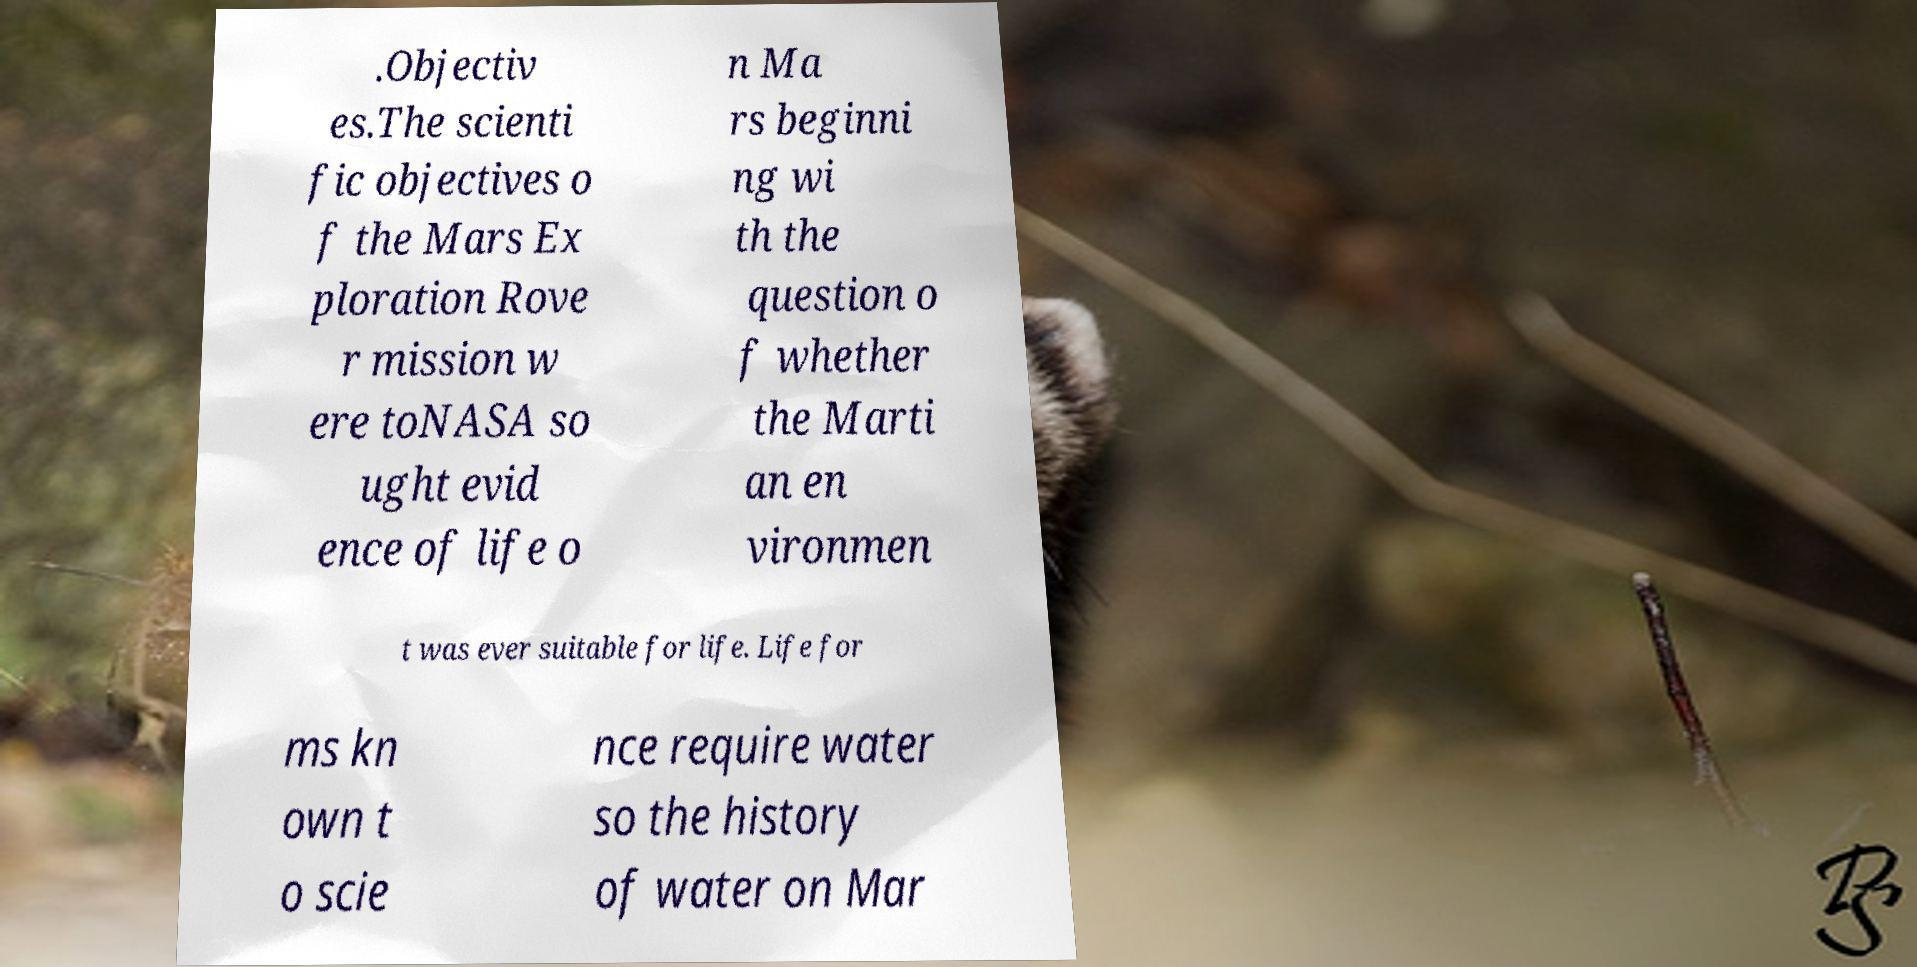Please read and relay the text visible in this image. What does it say? .Objectiv es.The scienti fic objectives o f the Mars Ex ploration Rove r mission w ere toNASA so ught evid ence of life o n Ma rs beginni ng wi th the question o f whether the Marti an en vironmen t was ever suitable for life. Life for ms kn own t o scie nce require water so the history of water on Mar 